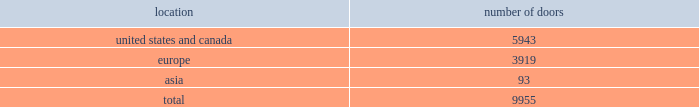Table of contents global brand concepts american living launched exclusively at jcpenney in february 2008 , american living offers classic american style with a fresh , modern spirit and authentic sensibility .
From everyday essentials to special occasion looks for the entire family to finely crafted bedding and home furnishings , american living promises stylish clothing and home products that are exceptionally made and offered at an incredible value .
American living is available exclusively at jcpenney and jcp.com .
Chaps translates the classic heritage and timeless aesthetic of ralph lauren into an accessible line for men , women , children and the home .
From casual basics designed for versatility and ease of wear to smart , finely tailored silhouettes perfect for business and more formal occasions , chaps creates interchangeable classics that are both enduring and affordable .
The chaps men 2019s collection is available at select department and specialty stores .
The chaps collections for women , children and the home are available exclusively at kohl 2019s and kohls.com .
Our wholesale segment our wholesale segment sells our products to leading upscale and certain mid-tier department stores , specialty stores and golf and pro shops , both domestically and internationally .
We have continued to focus on elevating our brand by improving in-store product assortment and presentation , and improving full-price sell-throughs to consumers .
As of the end of fiscal 2011 , our ralph lauren- branded products were sold through approximately 10000 doors worldwide and during fiscal 2011 , we invested approximately $ 35 million in related shop-within-shops primarily in domestic and international department and specialty stores .
Department stores are our major wholesale customers in north america .
In europe , our wholesale sales are a varying mix of sales to both department stores and specialty shops , depending on the country .
Our collection brands 2014 women 2019s ralph lauren collection and black label and men 2019s purple label and black label 2014 are distributed through a limited number of premier fashion retailers .
In addition , we sell excess and out-of-season products through secondary distribution channels , including our retail factory stores .
In japan , our wholesale products are distributed primarily through shop-within-shops at premiere and top-tier department stores , and the mix of business is weighted to women 2019s blue label .
In asia ( excluding japan and south korea ) , our wholesale products are sold at mid and top- tier department stores , and the mix of business is primarily weighted to men 2019s and women 2019s blue label .
In asia and on a worldwide basis , products distributed through concessions-based sales arrangements are reported within our retail segment ( see 201cour retail segment 201d for further discussion ) .
Worldwide distribution channels the table presents the number of doors by geographic location , in which ralph lauren-branded products distributed by our wholesale segment were sold to consumers in our primary channels of distribution as of april 2 , 2011 : number of location doors .
In addition , american living and chaps-branded products distributed by our wholesale segment were sold domestically through approximately 1700 doors as of april 2 , 2011. .
What percentage of total doors is the united states and canada geography? 
Computations: (5943 / 9955)
Answer: 0.59699. 